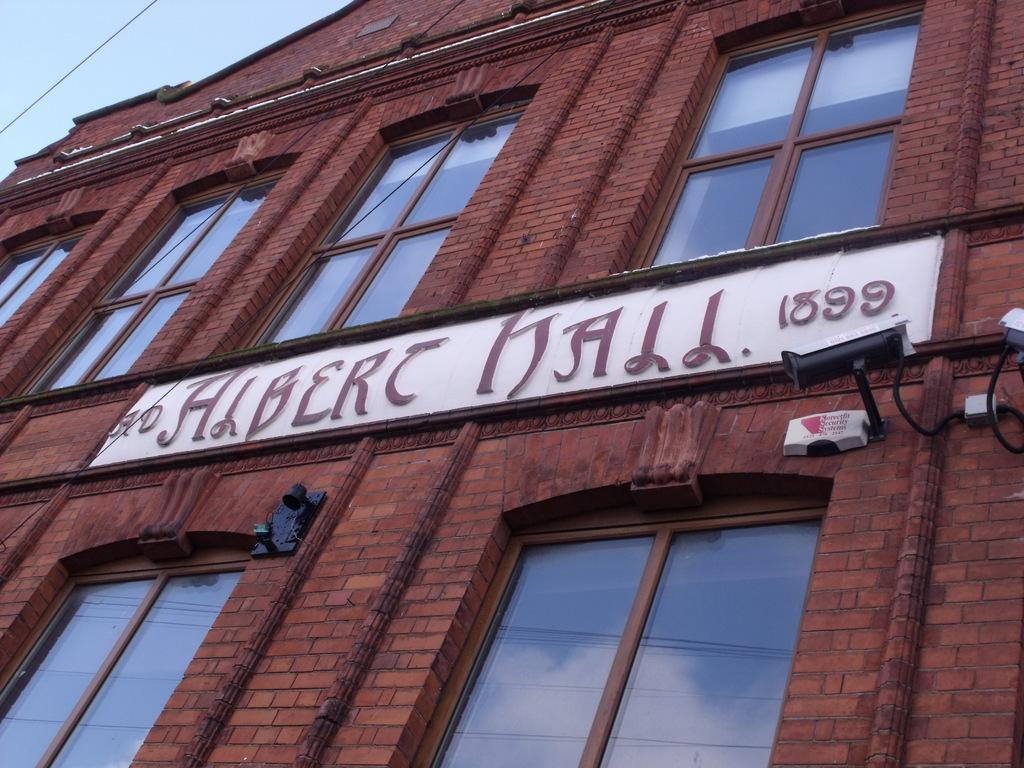In one or two sentences, can you explain what this image depicts? In this image we can see building with glass windows. We can see camera and board is attached to the building. 